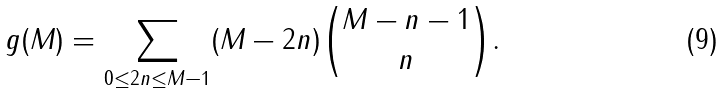Convert formula to latex. <formula><loc_0><loc_0><loc_500><loc_500>g ( M ) = \sum _ { 0 \leq 2 n \leq M - 1 } ( M - 2 n ) \binom { M - n - 1 } n .</formula> 